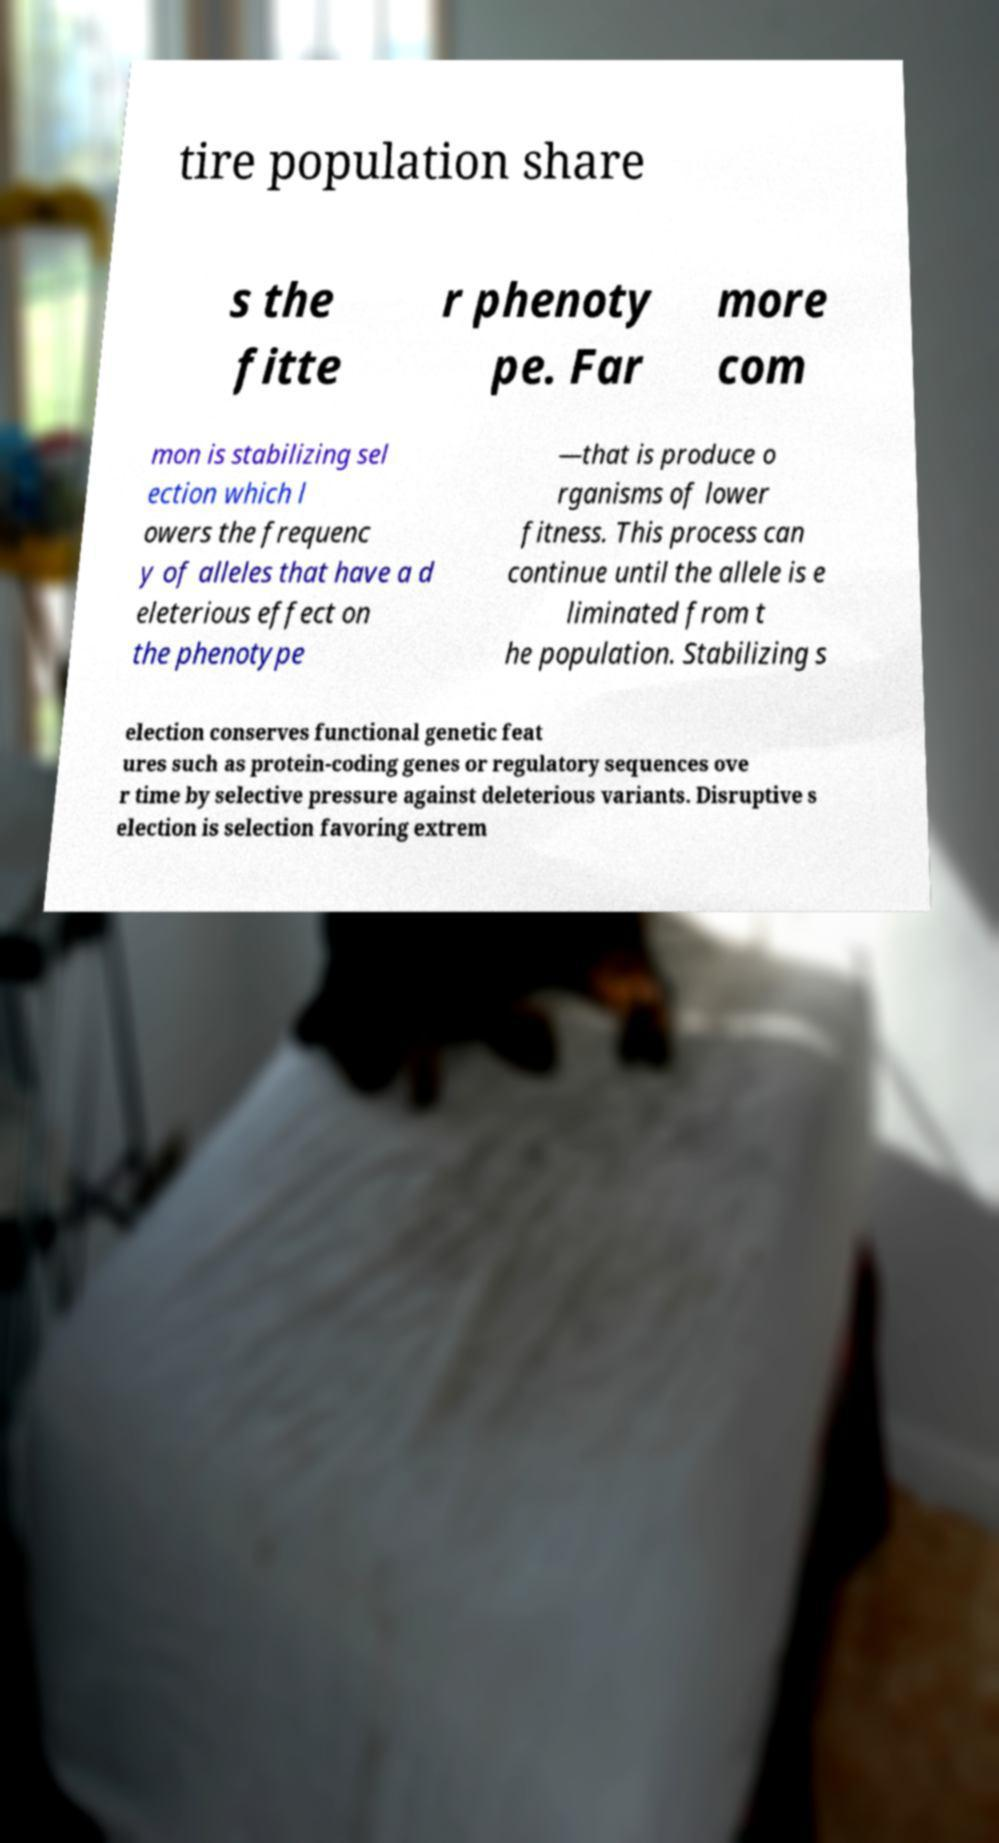Can you accurately transcribe the text from the provided image for me? tire population share s the fitte r phenoty pe. Far more com mon is stabilizing sel ection which l owers the frequenc y of alleles that have a d eleterious effect on the phenotype —that is produce o rganisms of lower fitness. This process can continue until the allele is e liminated from t he population. Stabilizing s election conserves functional genetic feat ures such as protein-coding genes or regulatory sequences ove r time by selective pressure against deleterious variants. Disruptive s election is selection favoring extrem 